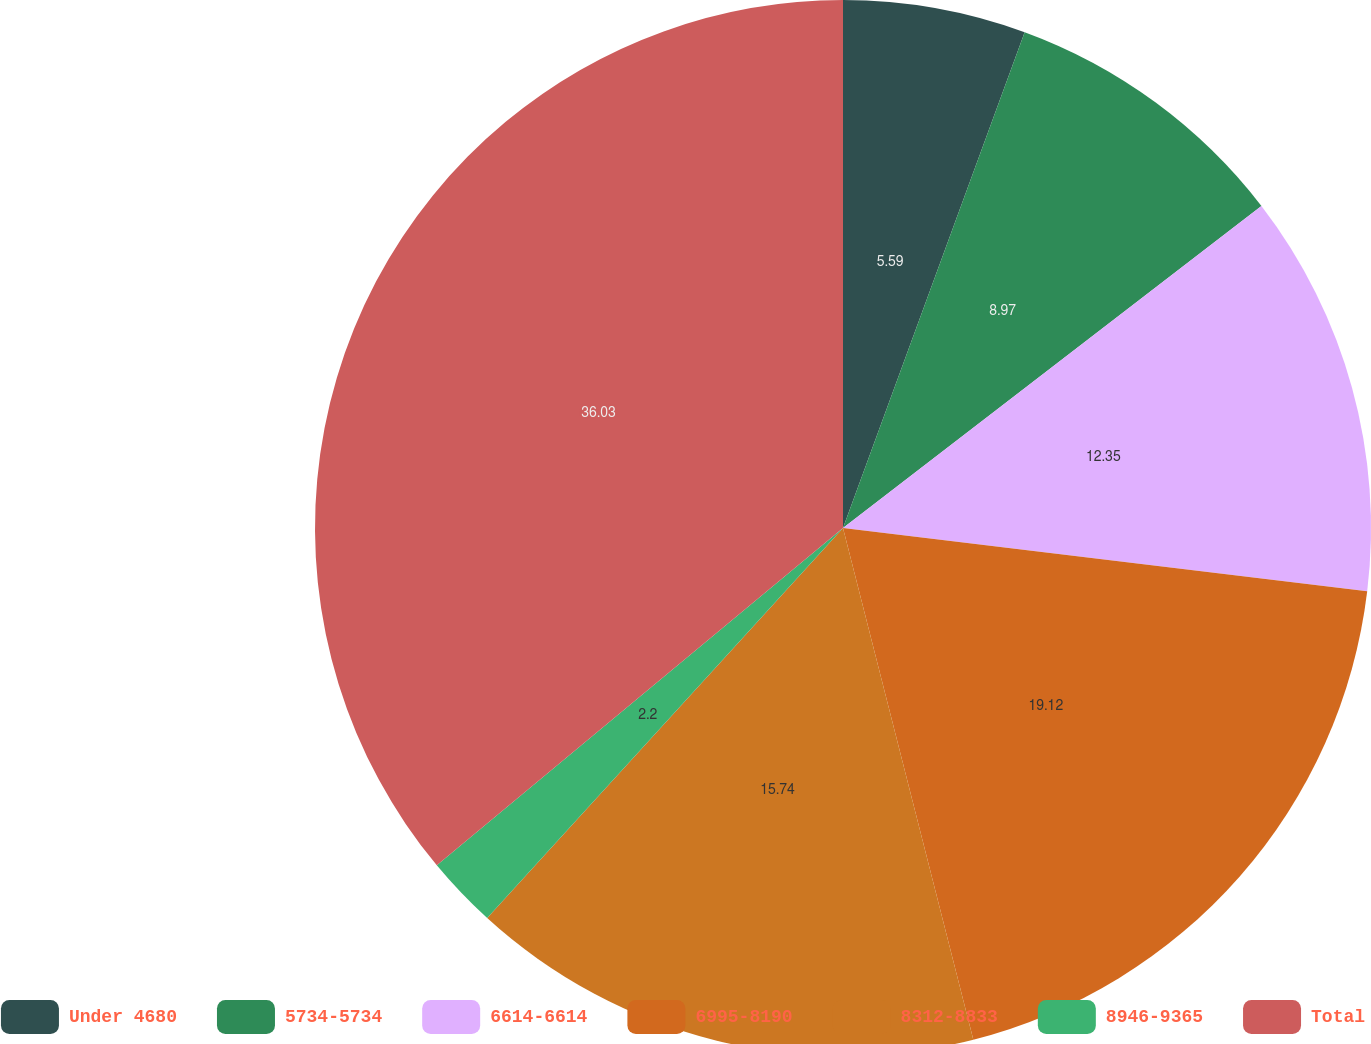<chart> <loc_0><loc_0><loc_500><loc_500><pie_chart><fcel>Under 4680<fcel>5734-5734<fcel>6614-6614<fcel>6995-8190<fcel>8312-8833<fcel>8946-9365<fcel>Total<nl><fcel>5.59%<fcel>8.97%<fcel>12.35%<fcel>19.12%<fcel>15.74%<fcel>2.2%<fcel>36.03%<nl></chart> 